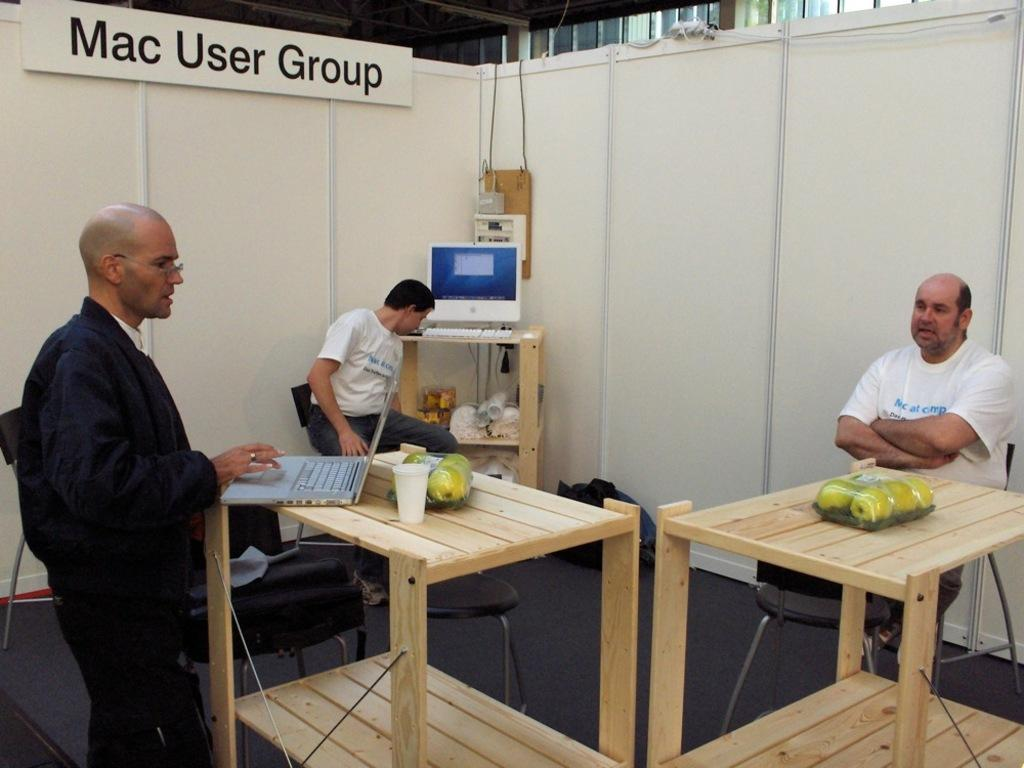<image>
Share a concise interpretation of the image provided. Three men who are part of the Mac User Group. 